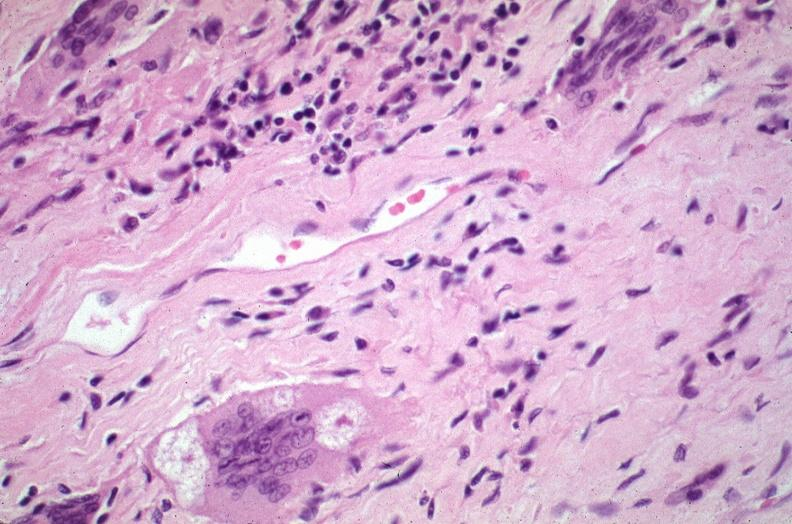where is this?
Answer the question using a single word or phrase. Lung 